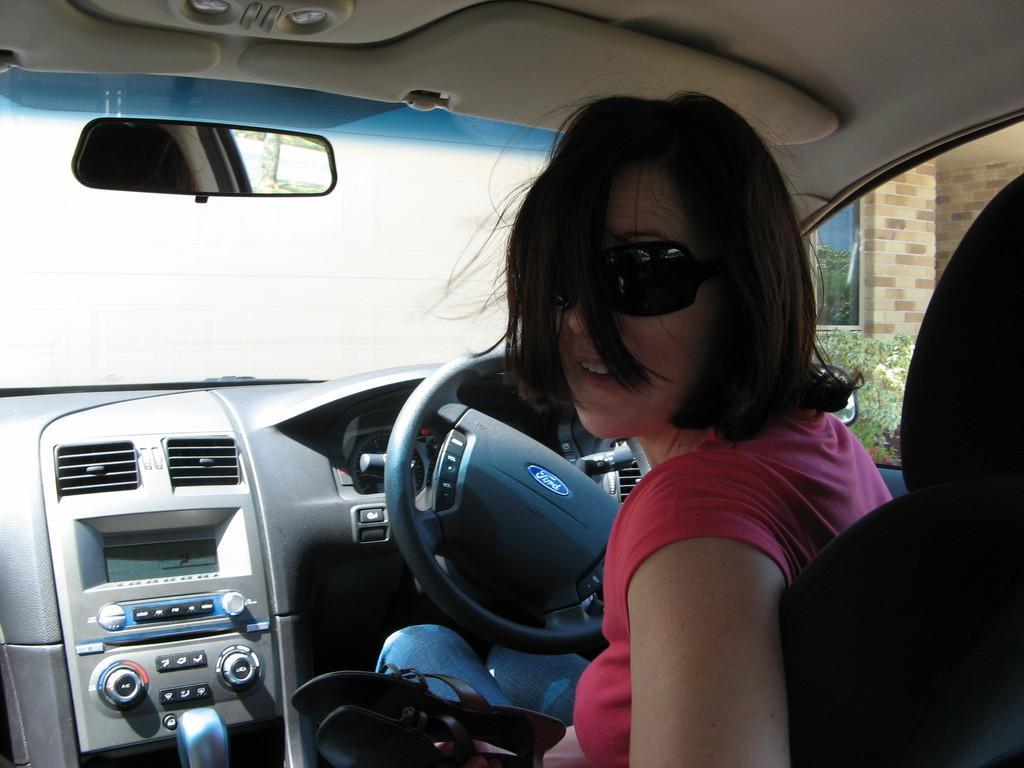Could you give a brief overview of what you see in this image? In this picture there is a lady who is riding a car at the right side of the image, she is looking behind her in the image. 